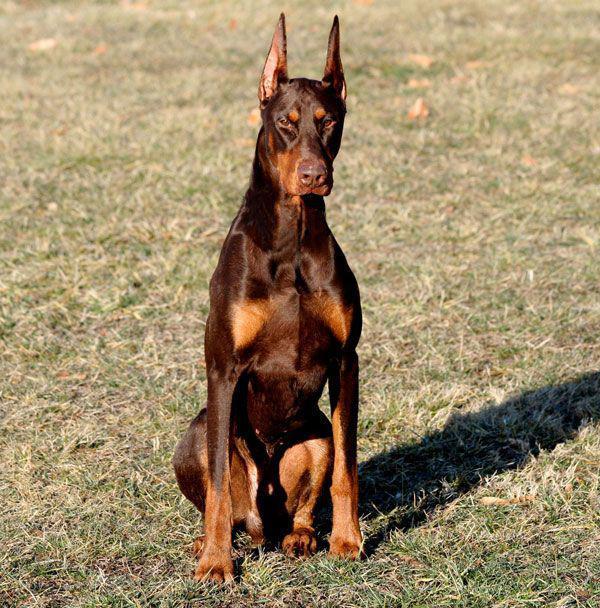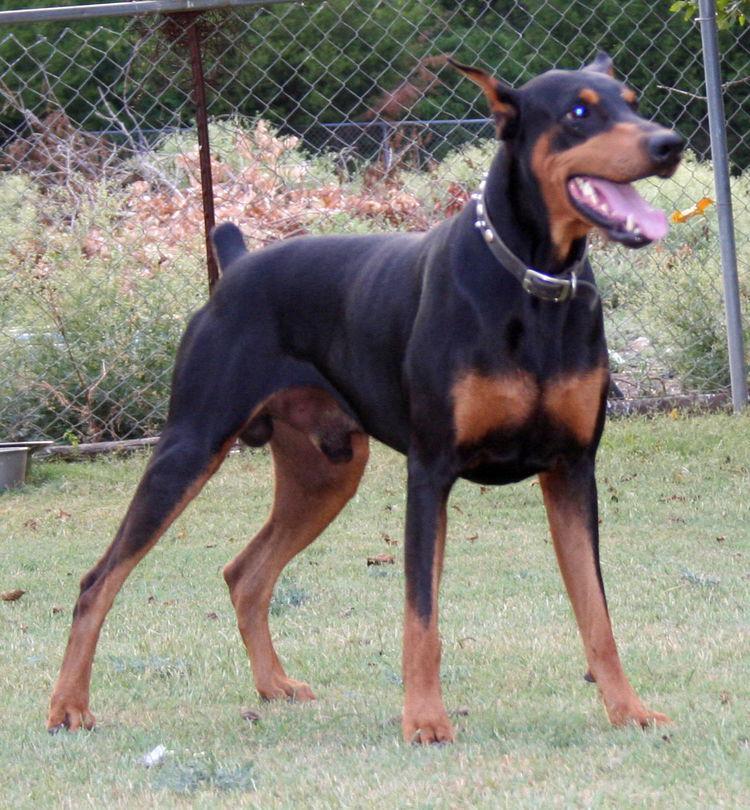The first image is the image on the left, the second image is the image on the right. For the images shown, is this caption "One black and one brown doberman pincer stand next to each other while they are outside." true? Answer yes or no. No. The first image is the image on the left, the second image is the image on the right. Evaluate the accuracy of this statement regarding the images: "There are exactly four dogs in total.". Is it true? Answer yes or no. No. 